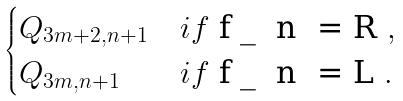Convert formula to latex. <formula><loc_0><loc_0><loc_500><loc_500>\begin{cases} Q _ { 3 m + 2 , n + 1 } & i f $ f _ { n } = R $ , \\ Q _ { 3 m , n + 1 } & i f $ f _ { n } = L $ . \end{cases}</formula> 